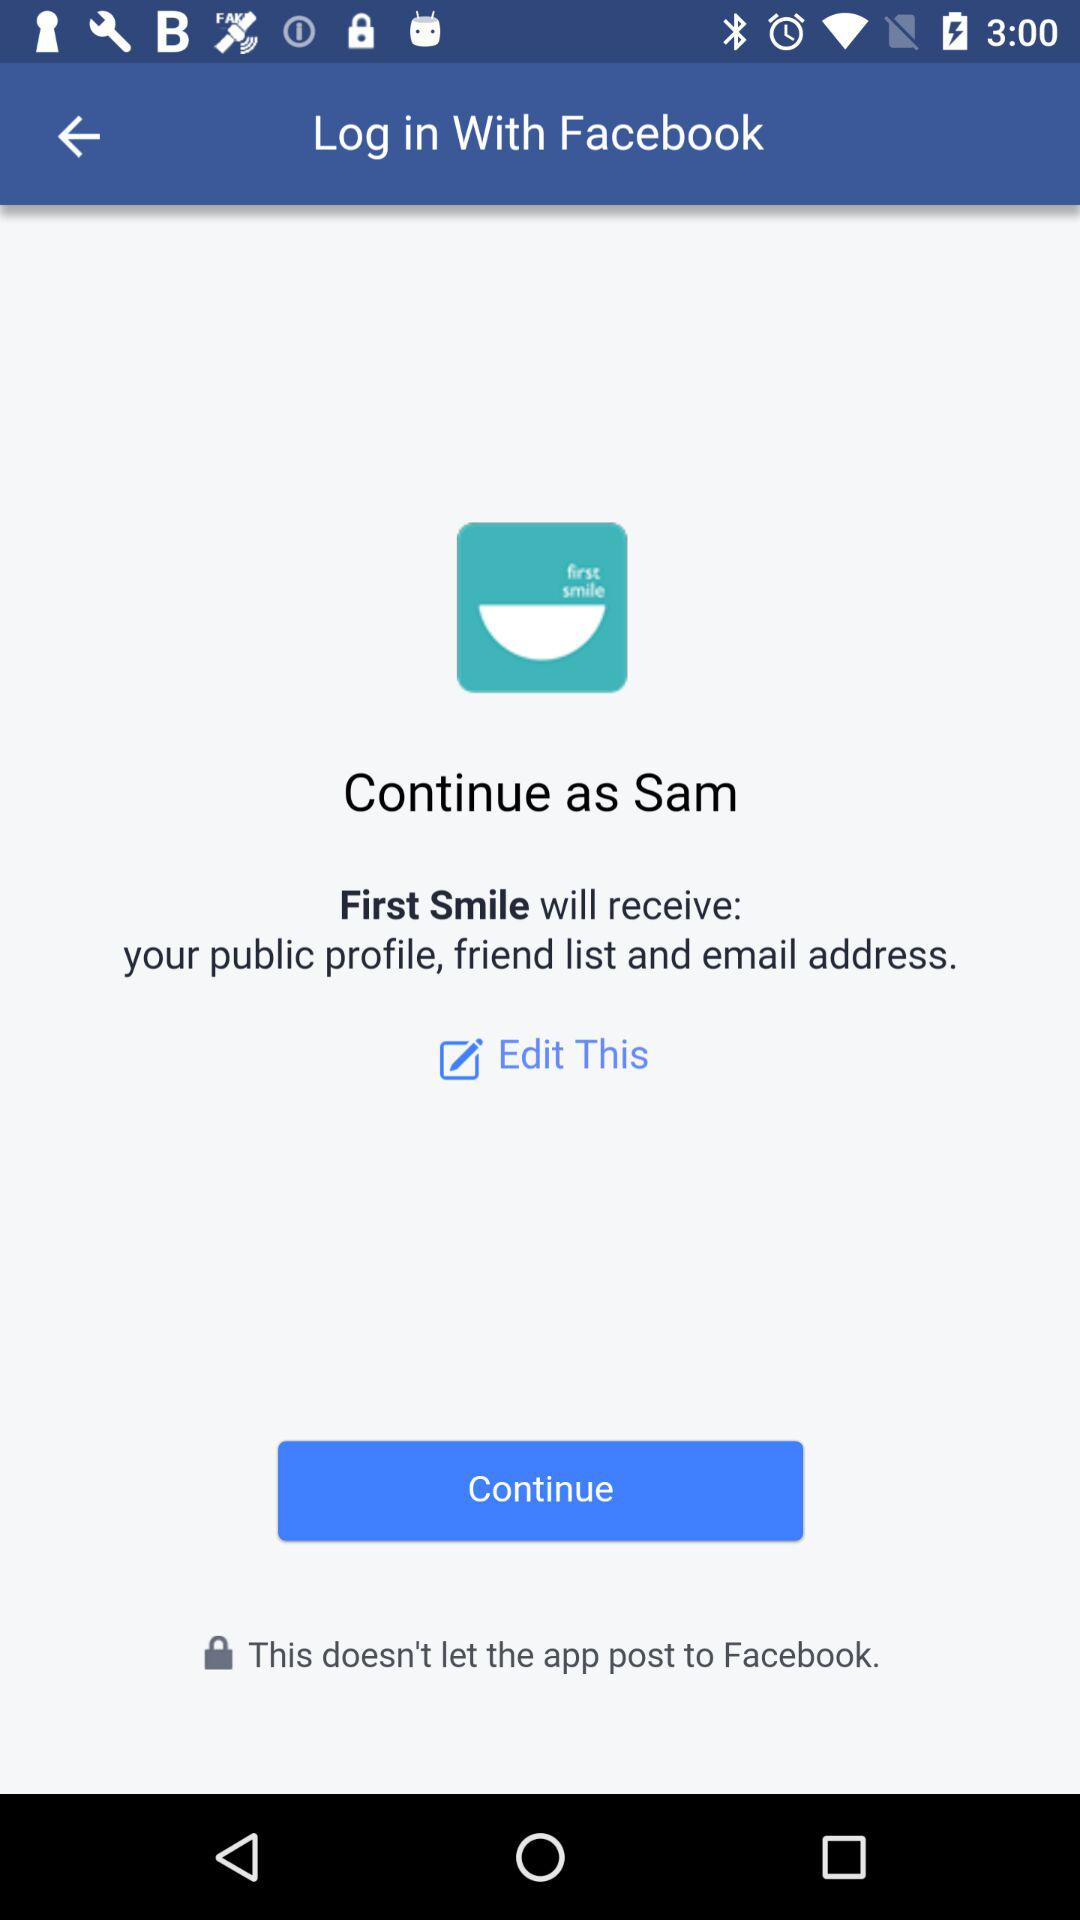What application is asking for permission? The application asking for permission is "First Smile". 